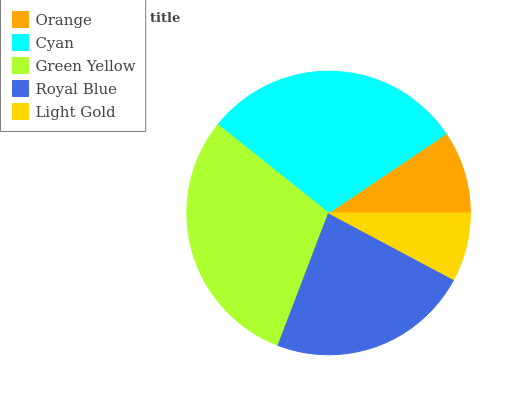Is Light Gold the minimum?
Answer yes or no. Yes. Is Green Yellow the maximum?
Answer yes or no. Yes. Is Cyan the minimum?
Answer yes or no. No. Is Cyan the maximum?
Answer yes or no. No. Is Cyan greater than Orange?
Answer yes or no. Yes. Is Orange less than Cyan?
Answer yes or no. Yes. Is Orange greater than Cyan?
Answer yes or no. No. Is Cyan less than Orange?
Answer yes or no. No. Is Royal Blue the high median?
Answer yes or no. Yes. Is Royal Blue the low median?
Answer yes or no. Yes. Is Light Gold the high median?
Answer yes or no. No. Is Orange the low median?
Answer yes or no. No. 